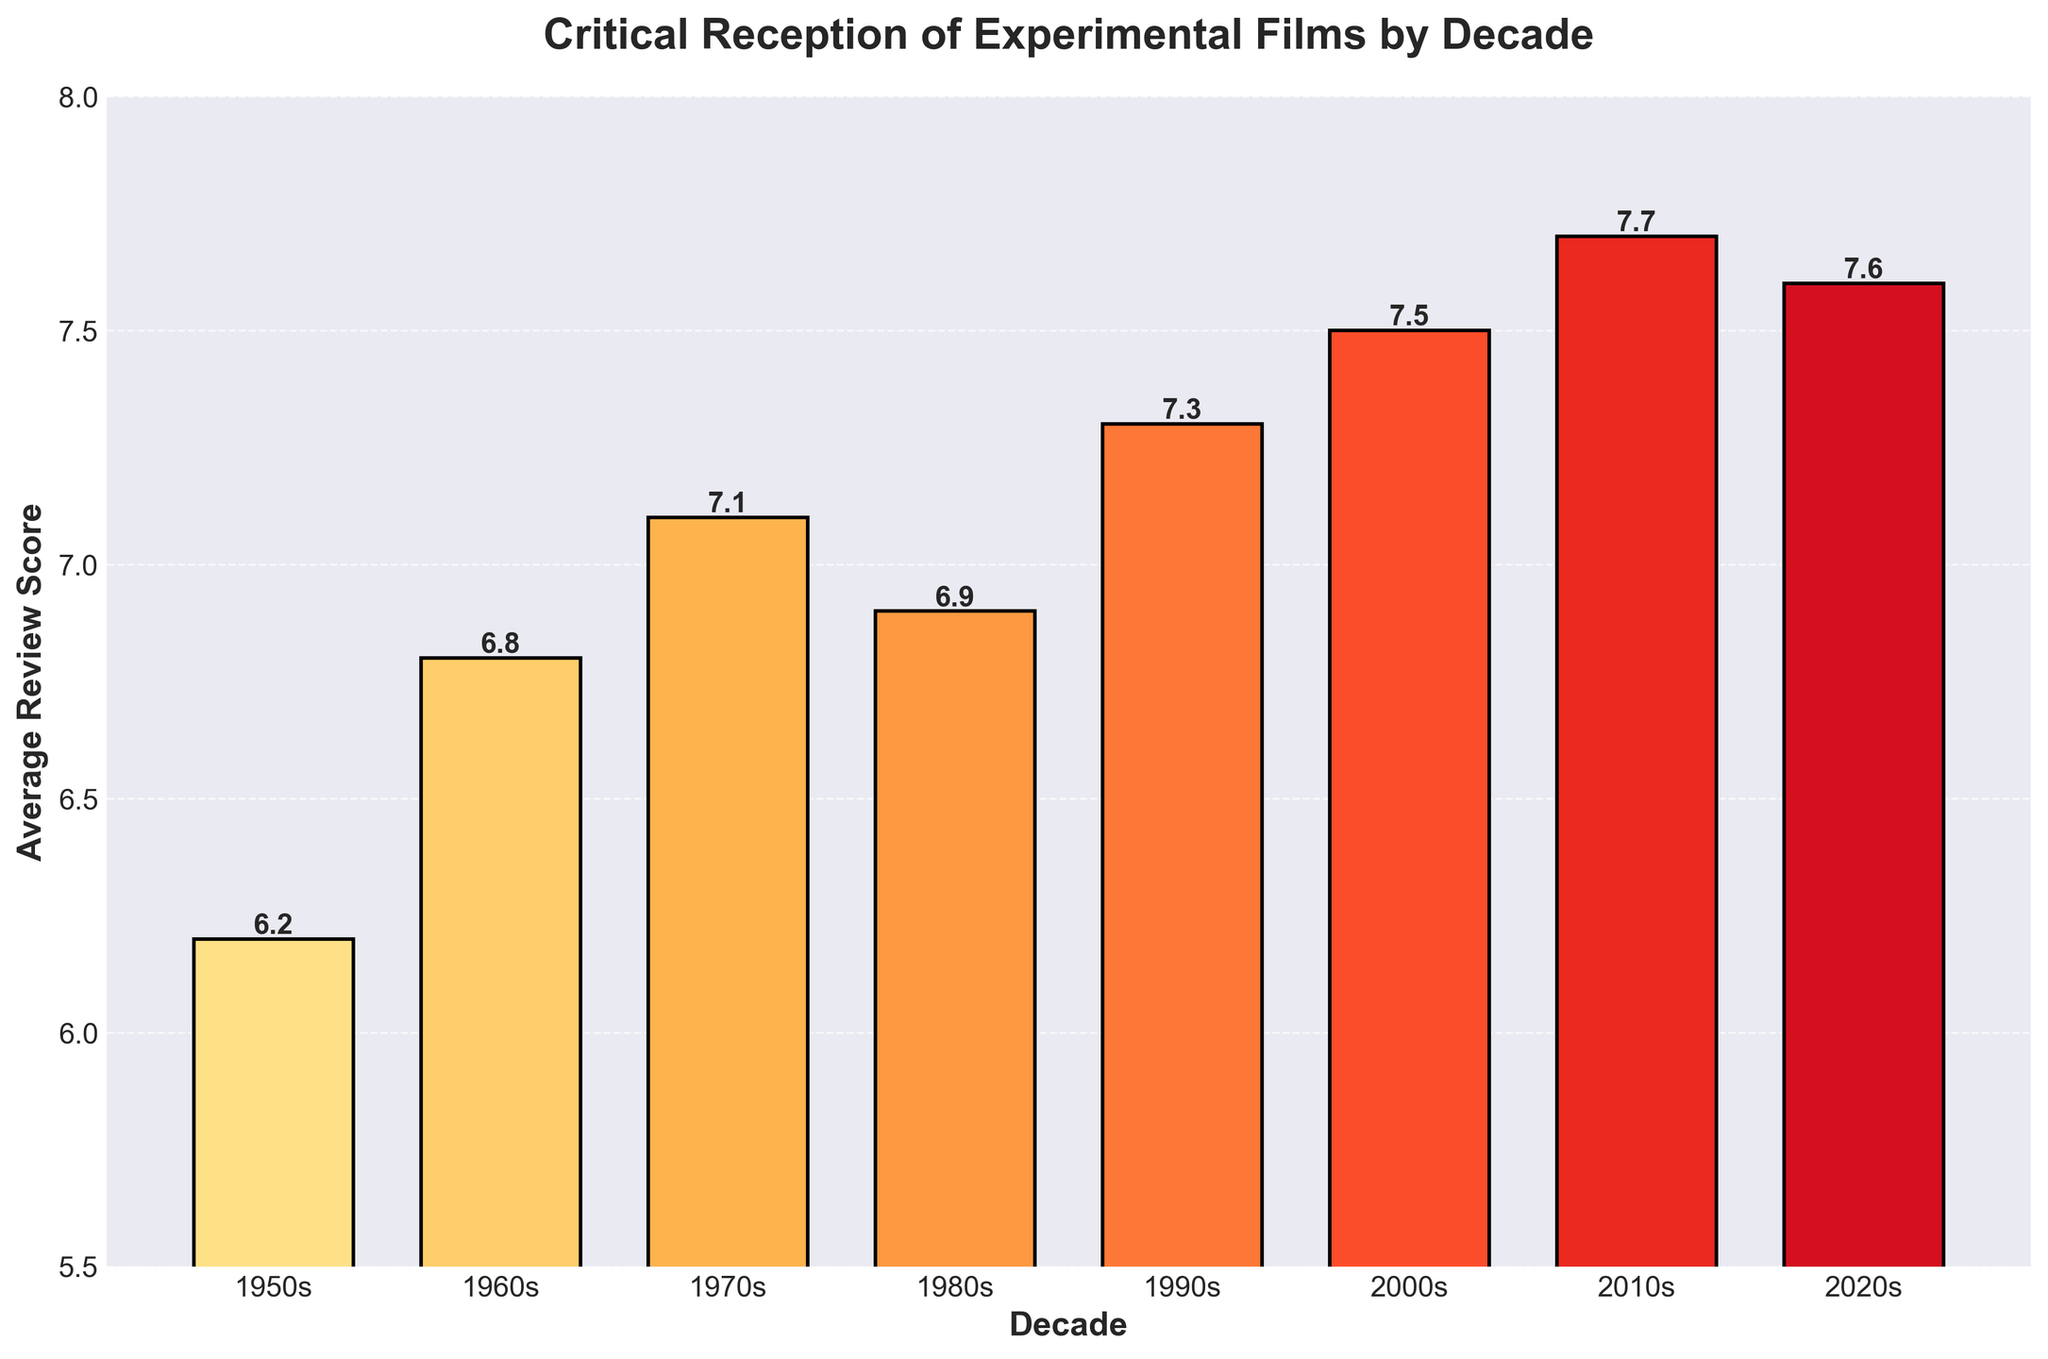What decade had the highest average review score for experimental films? The bar representing the 2010s reaches the highest point compared to other bars.
Answer: 2010s How many decades had an average review score below 7.0? By reviewing each bar, we notice that the bars for the 1950s, 1960s, and 1980s are below the 7.0 mark. This sums to 3 decades.
Answer: 3 Which decades had an average review score higher than 7.0 but less than 7.5? From the plot, we can identify that the 1970s (7.1) and 1990s (7.3) fall in this range.
Answer: 1970s and 1990s What is the sum of the average review scores for the 2000s and 2010s? The average review score for 2000s is 7.5. The average review score for 2010s is 7.7. Adding these scores: 7.5 + 7.7 = 15.2
Answer: 15.2 By how much did the average review score increase from the 1950s to the 2020s? The average review score in the 1950s is 6.2 and in the 2020s is 7.6. The difference between these is: 7.6 - 6.2 = 1.4.
Answer: 1.4 Which decade had a slight decrease in average review score compared to the previous decade? Comparing each consecutive bar, we see that the 2020s (7.6) had a slight decrease from the 2010s (7.7).
Answer: 2020s What is the average of the average review scores from the 1950s to the 2020s? Adding all the average review scores (6.2 + 6.8 + 7.1 + 6.9 + 7.3 + 7.5 + 7.7 + 7.6) yields 57.1. Dividing this sum by the number of decades (8), we get an average: 57.1 / 8 = 7.1
Answer: 7.1 Which decade saw the largest increase in average review score compared to the previous decade? Calculating the differences between consecutive decades: 1960s-1950s (0.6), 1970s-1960s (0.3), 1980s-1970s (-0.2), 1990s-1980s (0.4), 2000s-1990s (0.2), 2010s-2000s (0.2), 2020s-2010s (-0.1). The largest increase is from 1950s to 1960s.
Answer: 1960s How does the bar color change as the decades progress? The bars’ colors transition from lighter to darker shades of orange-red as we move from the 1950s to the 2020s.
Answer: Darker 